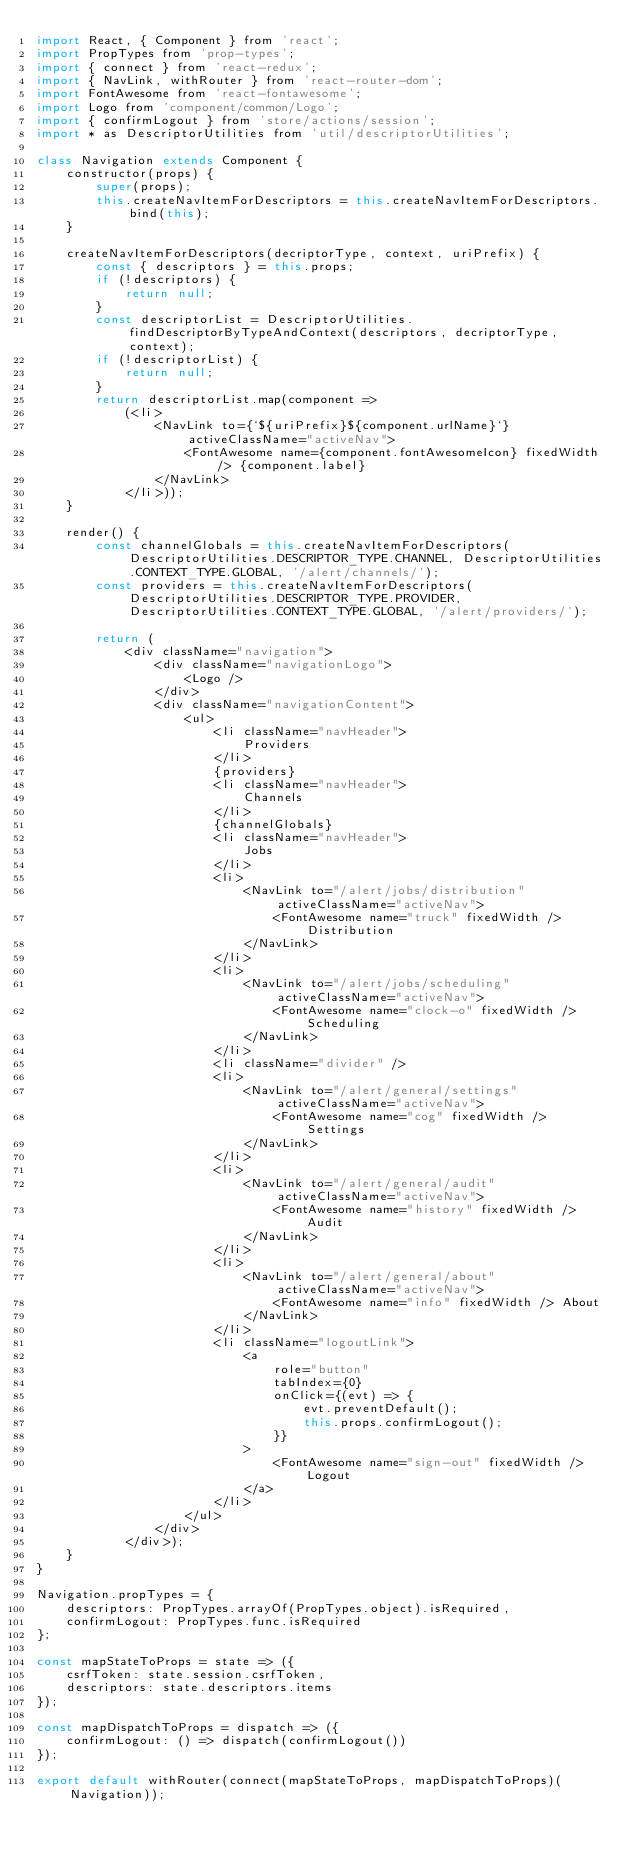<code> <loc_0><loc_0><loc_500><loc_500><_JavaScript_>import React, { Component } from 'react';
import PropTypes from 'prop-types';
import { connect } from 'react-redux';
import { NavLink, withRouter } from 'react-router-dom';
import FontAwesome from 'react-fontawesome';
import Logo from 'component/common/Logo';
import { confirmLogout } from 'store/actions/session';
import * as DescriptorUtilities from 'util/descriptorUtilities';

class Navigation extends Component {
    constructor(props) {
        super(props);
        this.createNavItemForDescriptors = this.createNavItemForDescriptors.bind(this);
    }

    createNavItemForDescriptors(decriptorType, context, uriPrefix) {
        const { descriptors } = this.props;
        if (!descriptors) {
            return null;
        }
        const descriptorList = DescriptorUtilities.findDescriptorByTypeAndContext(descriptors, decriptorType, context);
        if (!descriptorList) {
            return null;
        }
        return descriptorList.map(component =>
            (<li>
                <NavLink to={`${uriPrefix}${component.urlName}`} activeClassName="activeNav">
                    <FontAwesome name={component.fontAwesomeIcon} fixedWidth /> {component.label}
                </NavLink>
            </li>));
    }

    render() {
        const channelGlobals = this.createNavItemForDescriptors(DescriptorUtilities.DESCRIPTOR_TYPE.CHANNEL, DescriptorUtilities.CONTEXT_TYPE.GLOBAL, '/alert/channels/');
        const providers = this.createNavItemForDescriptors(DescriptorUtilities.DESCRIPTOR_TYPE.PROVIDER, DescriptorUtilities.CONTEXT_TYPE.GLOBAL, '/alert/providers/');

        return (
            <div className="navigation">
                <div className="navigationLogo">
                    <Logo />
                </div>
                <div className="navigationContent">
                    <ul>
                        <li className="navHeader">
                            Providers
                        </li>
                        {providers}
                        <li className="navHeader">
                            Channels
                        </li>
                        {channelGlobals}
                        <li className="navHeader">
                            Jobs
                        </li>
                        <li>
                            <NavLink to="/alert/jobs/distribution" activeClassName="activeNav">
                                <FontAwesome name="truck" fixedWidth /> Distribution
                            </NavLink>
                        </li>
                        <li>
                            <NavLink to="/alert/jobs/scheduling" activeClassName="activeNav">
                                <FontAwesome name="clock-o" fixedWidth /> Scheduling
                            </NavLink>
                        </li>
                        <li className="divider" />
                        <li>
                            <NavLink to="/alert/general/settings" activeClassName="activeNav">
                                <FontAwesome name="cog" fixedWidth /> Settings
                            </NavLink>
                        </li>
                        <li>
                            <NavLink to="/alert/general/audit" activeClassName="activeNav">
                                <FontAwesome name="history" fixedWidth /> Audit
                            </NavLink>
                        </li>
                        <li>
                            <NavLink to="/alert/general/about" activeClassName="activeNav">
                                <FontAwesome name="info" fixedWidth /> About
                            </NavLink>
                        </li>
                        <li className="logoutLink">
                            <a
                                role="button"
                                tabIndex={0}
                                onClick={(evt) => {
                                    evt.preventDefault();
                                    this.props.confirmLogout();
                                }}
                            >
                                <FontAwesome name="sign-out" fixedWidth /> Logout
                            </a>
                        </li>
                    </ul>
                </div>
            </div>);
    }
}

Navigation.propTypes = {
    descriptors: PropTypes.arrayOf(PropTypes.object).isRequired,
    confirmLogout: PropTypes.func.isRequired
};

const mapStateToProps = state => ({
    csrfToken: state.session.csrfToken,
    descriptors: state.descriptors.items
});

const mapDispatchToProps = dispatch => ({
    confirmLogout: () => dispatch(confirmLogout())
});

export default withRouter(connect(mapStateToProps, mapDispatchToProps)(Navigation));
</code> 